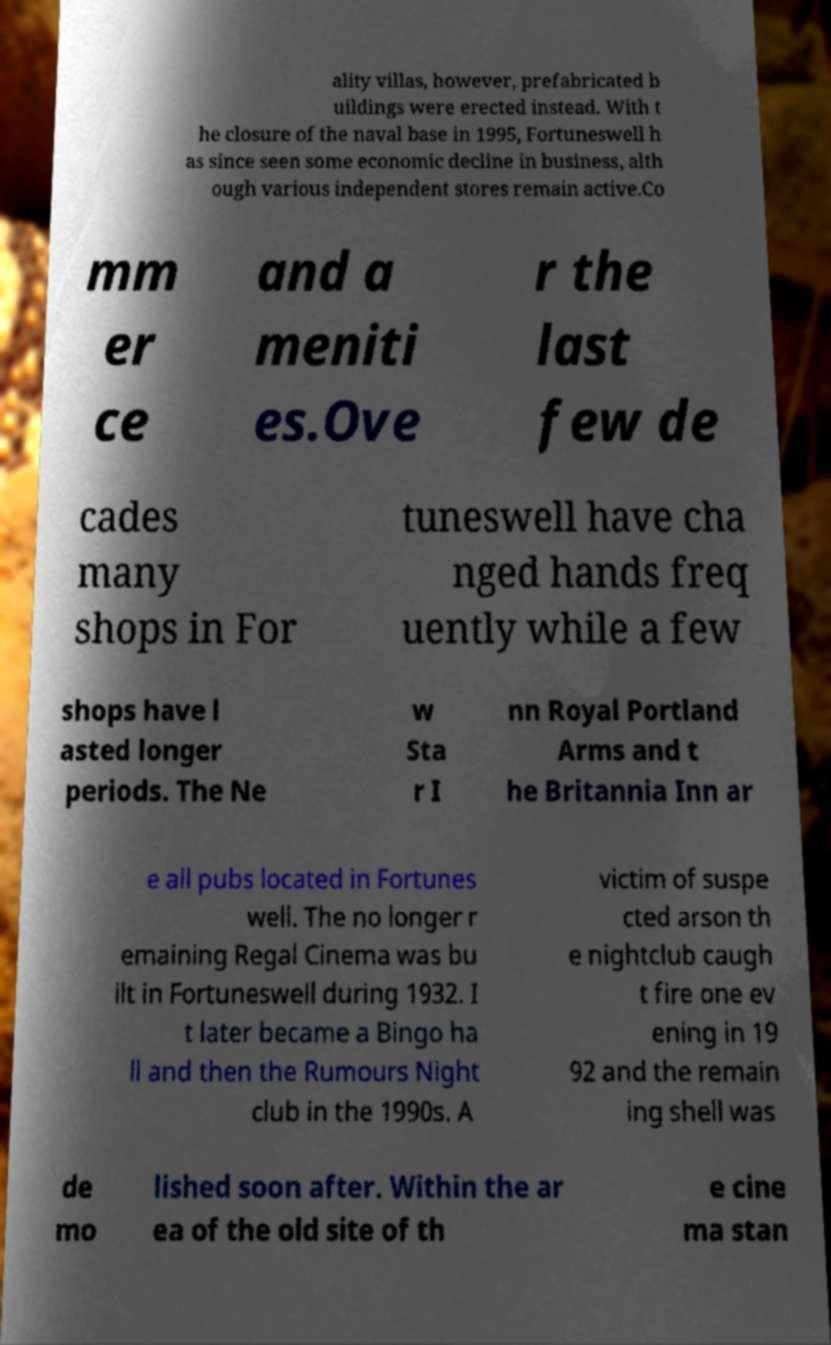Can you accurately transcribe the text from the provided image for me? ality villas, however, prefabricated b uildings were erected instead. With t he closure of the naval base in 1995, Fortuneswell h as since seen some economic decline in business, alth ough various independent stores remain active.Co mm er ce and a meniti es.Ove r the last few de cades many shops in For tuneswell have cha nged hands freq uently while a few shops have l asted longer periods. The Ne w Sta r I nn Royal Portland Arms and t he Britannia Inn ar e all pubs located in Fortunes well. The no longer r emaining Regal Cinema was bu ilt in Fortuneswell during 1932. I t later became a Bingo ha ll and then the Rumours Night club in the 1990s. A victim of suspe cted arson th e nightclub caugh t fire one ev ening in 19 92 and the remain ing shell was de mo lished soon after. Within the ar ea of the old site of th e cine ma stan 